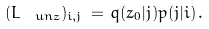<formula> <loc_0><loc_0><loc_500><loc_500>( L _ { \ u n { z } } ) _ { i , j } \, = \, q ( z _ { 0 } | j ) p ( j | i ) \, .</formula> 